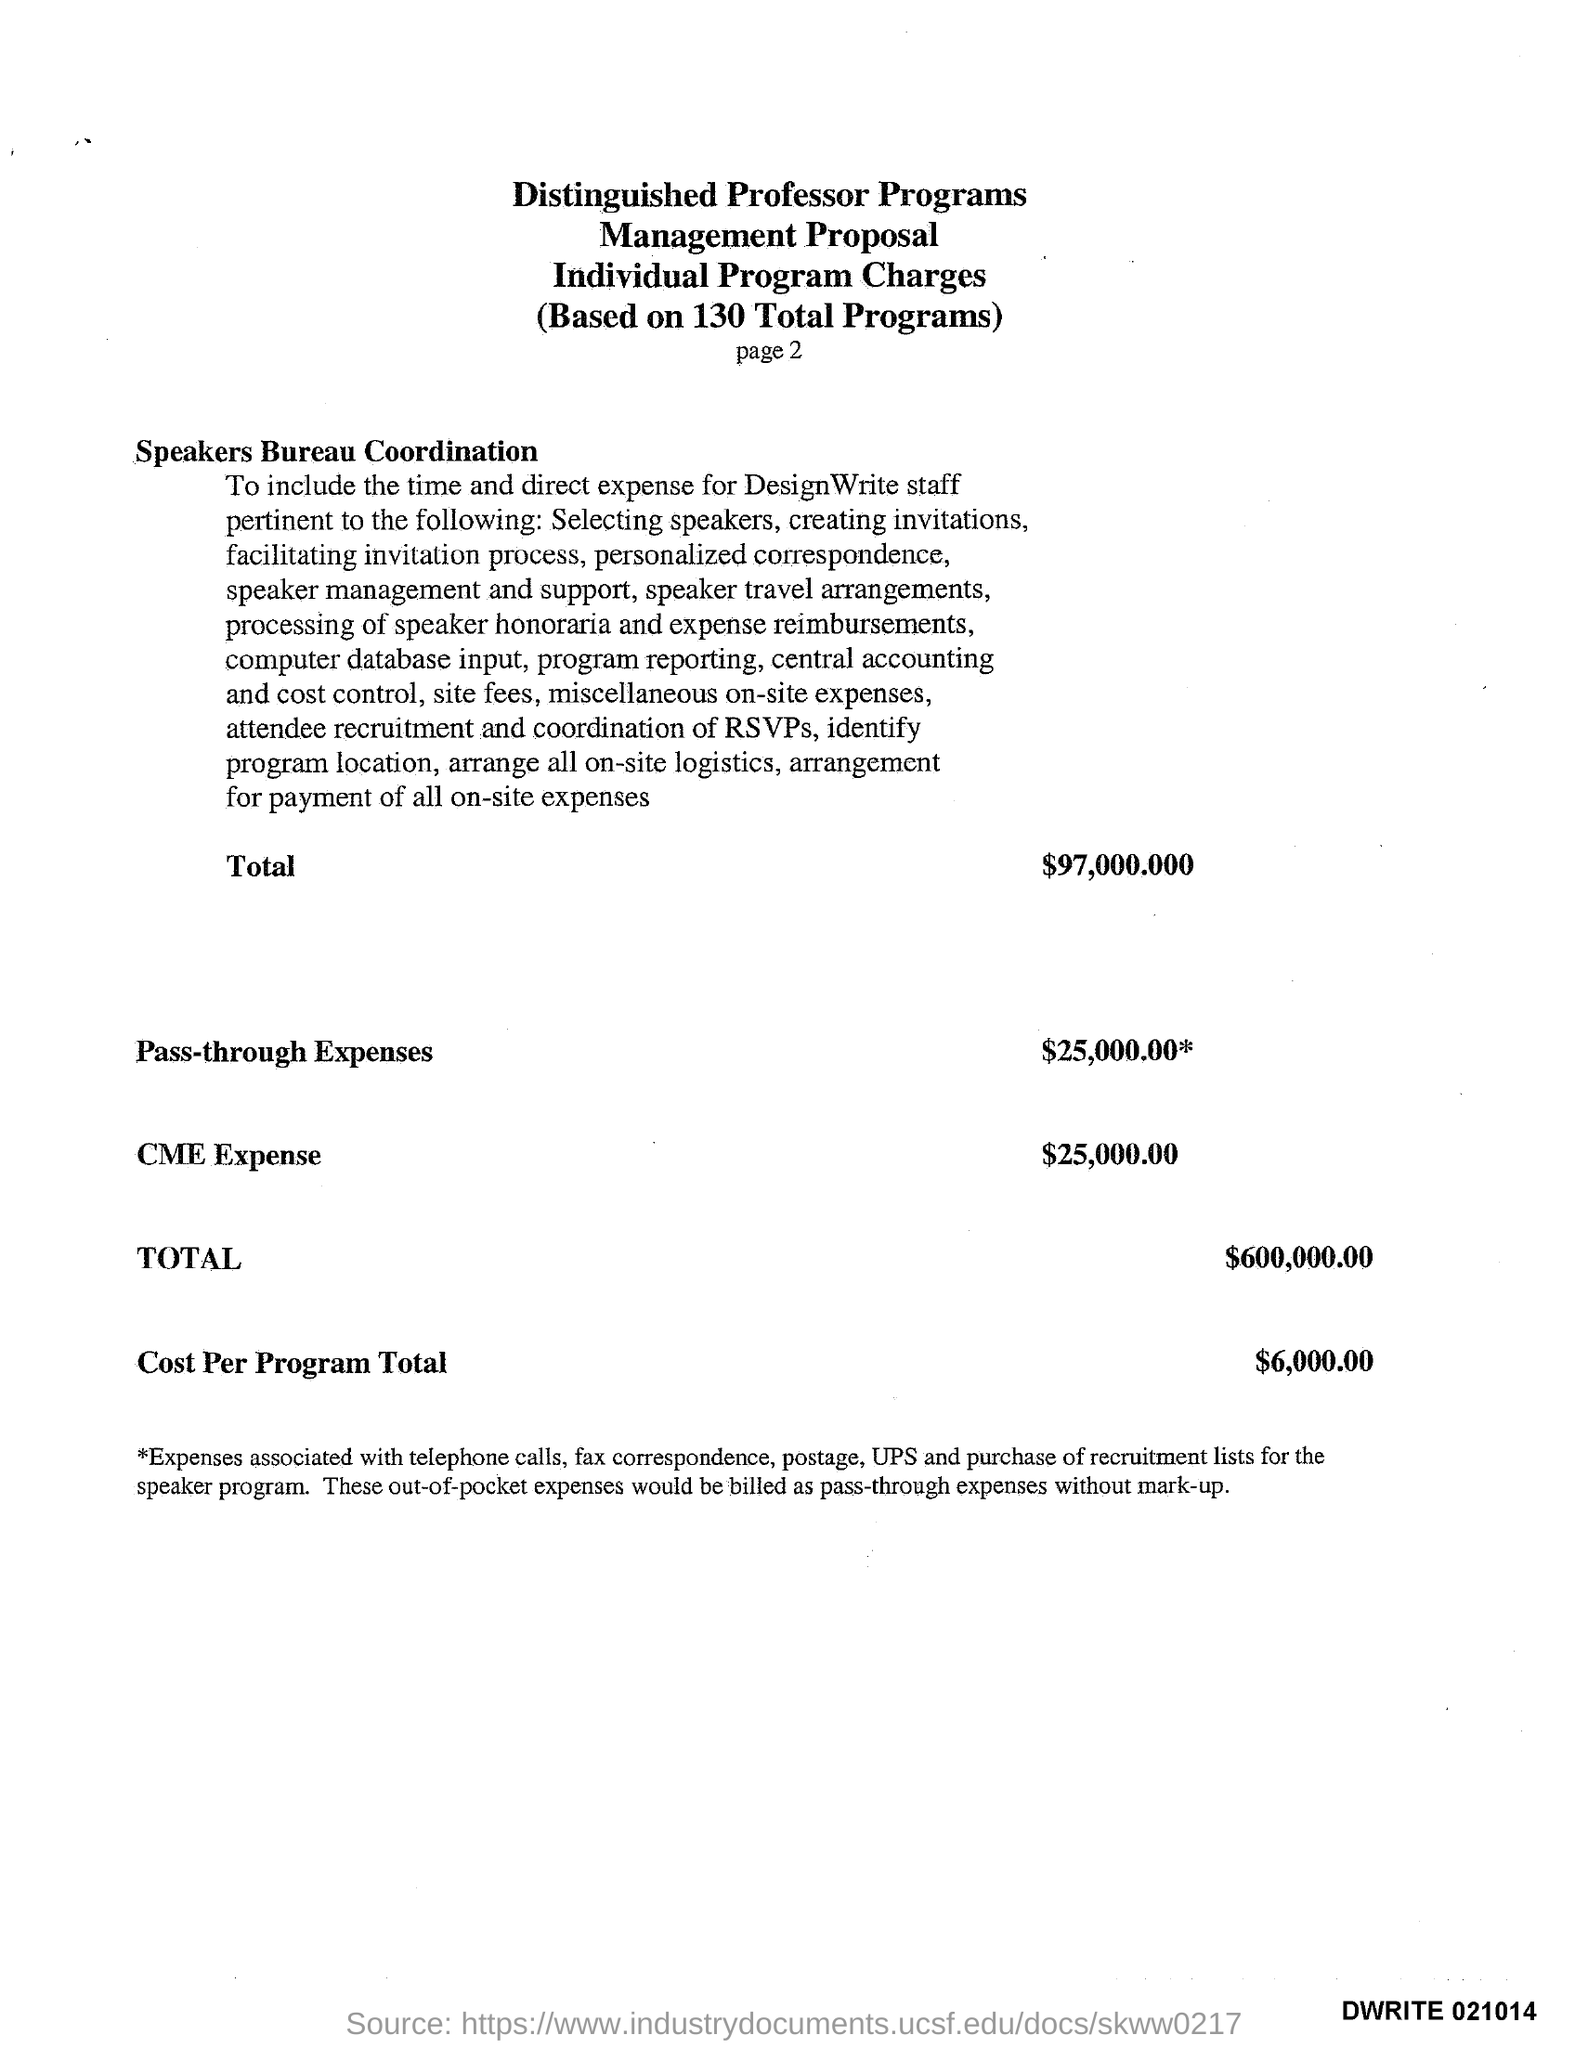Draw attention to some important aspects in this diagram. The pass-through expenses amount to $25,000.00. The CME expense is $25,000. The total cost for the programs is $6,000.00. 